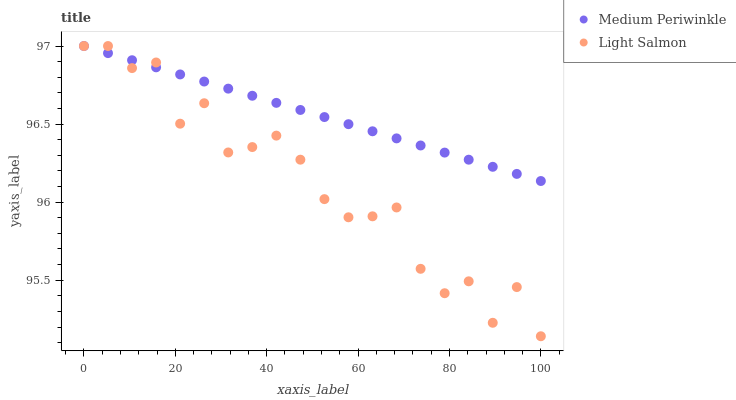Does Light Salmon have the minimum area under the curve?
Answer yes or no. Yes. Does Medium Periwinkle have the maximum area under the curve?
Answer yes or no. Yes. Does Medium Periwinkle have the minimum area under the curve?
Answer yes or no. No. Is Medium Periwinkle the smoothest?
Answer yes or no. Yes. Is Light Salmon the roughest?
Answer yes or no. Yes. Is Medium Periwinkle the roughest?
Answer yes or no. No. Does Light Salmon have the lowest value?
Answer yes or no. Yes. Does Medium Periwinkle have the lowest value?
Answer yes or no. No. Does Medium Periwinkle have the highest value?
Answer yes or no. Yes. Does Medium Periwinkle intersect Light Salmon?
Answer yes or no. Yes. Is Medium Periwinkle less than Light Salmon?
Answer yes or no. No. Is Medium Periwinkle greater than Light Salmon?
Answer yes or no. No. 